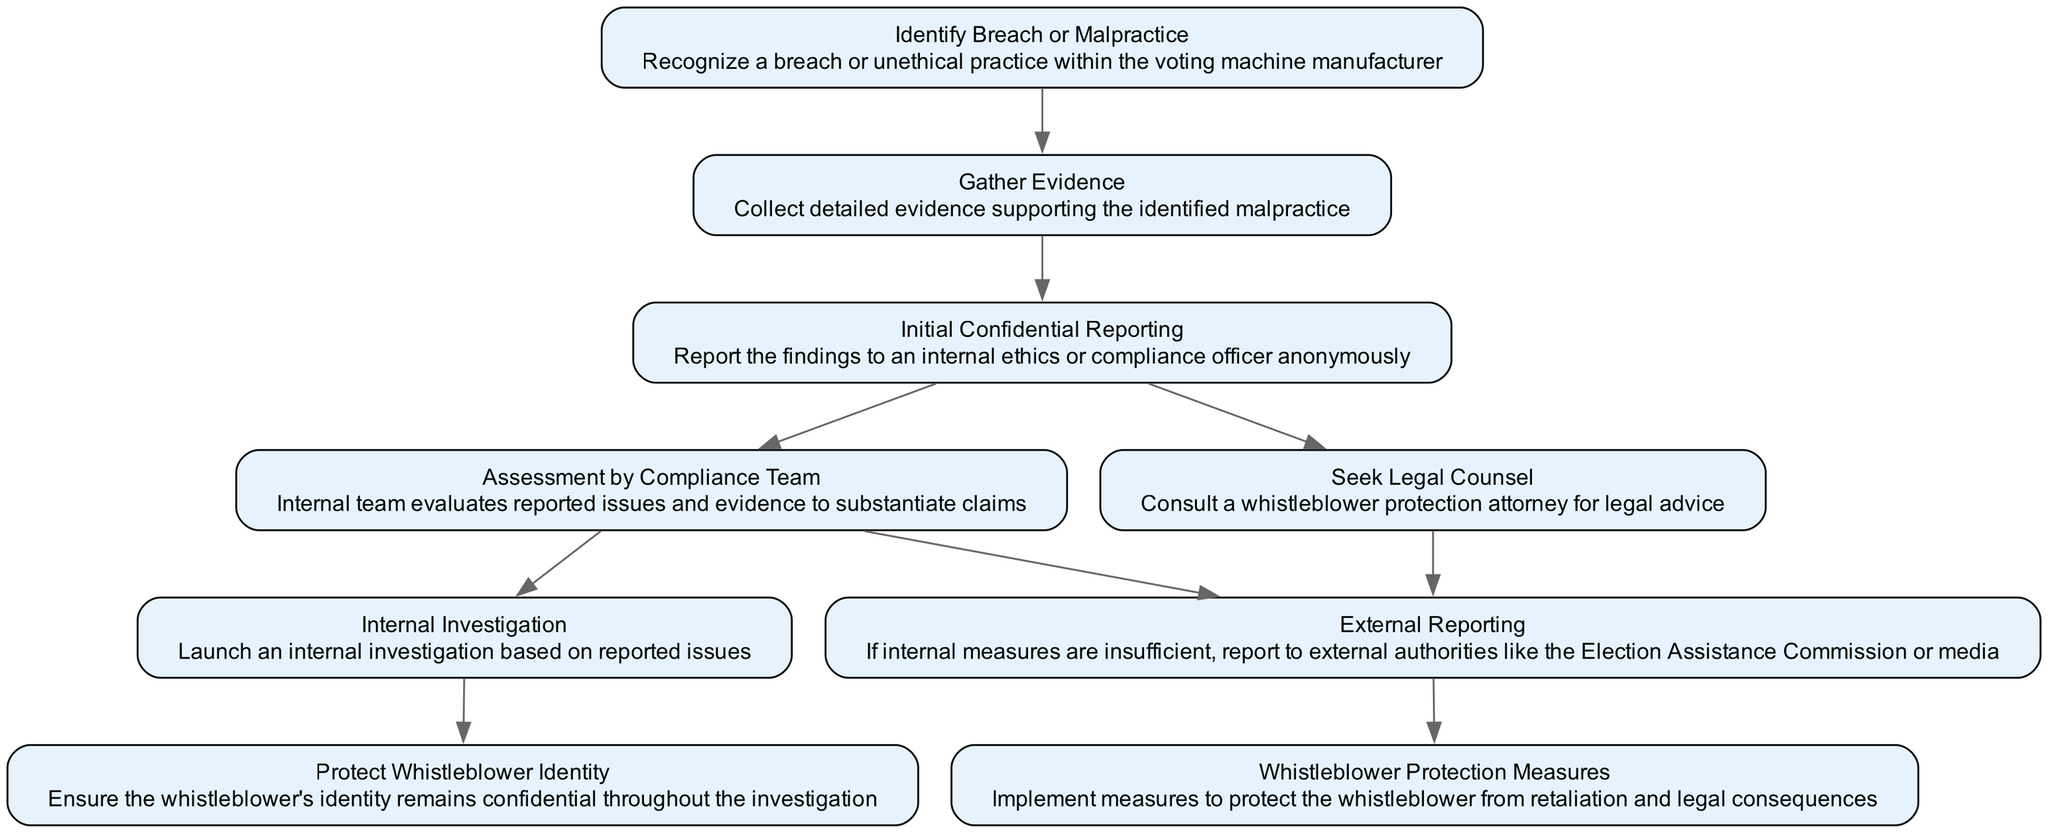What is the first step in the protocol? The first step is to identify a breach or malpractice within the voting machine manufacturer, as indicated by the node that represents this action.
Answer: Identify Breach or Malpractice How many outputs are associated with the "Initial Confidential Reporting" step? The "Initial Confidential Reporting" node outputs to two nodes, which are "Assessment by Compliance Team" and "Seek Legal Counsel". This is visible in the outputs listed under that node.
Answer: Two What follows after "Assessment by Compliance Team"? The output of the "Assessment by Compliance Team" node leads to two results: "Internal Investigation" and "External Reporting", which shows the possible next steps from this assessment.
Answer: Internal Investigation and External Reporting Which node signifies protecting the whistleblower's identity? The "Protect Whistleblower Identity" node explicitly states its purpose, which is to ensure confidentiality for the whistleblower during the investigation.
Answer: Protect Whistleblower Identity What action should be taken if internal measures are insufficient? The next action in such a case is to report to external authorities, which is represented by the "External Reporting" node in the flowchart.
Answer: External Reporting What is the relationship between "Gather Evidence" and "Initial Confidential Reporting"? "Gather Evidence" serves as an input to "Initial Confidential Reporting", meaning evidence collection is necessary before reporting the findings confidentially. This relationship is indicated by the arrows in the diagram.
Answer: Input What does the "Seek Legal Counsel" step advise? This step advises to consult a whistleblower protection attorney for legal advice, as stated in its description within the node.
Answer: Consult a whistleblower protection attorney What happens after an "Internal Investigation" is launched? The "Internal Investigation" node does not have any outputs listed, which indicates that its completion may lead to further actions being taken regarding the case, but it's not detailed in this diagram.
Answer: None Which node implements measures to protect whistleblowers from retaliation? The node titled "Whistleblower Protection Measures" specifies this action, indicating its role in implementing protective measures.
Answer: Whistleblower Protection Measures 